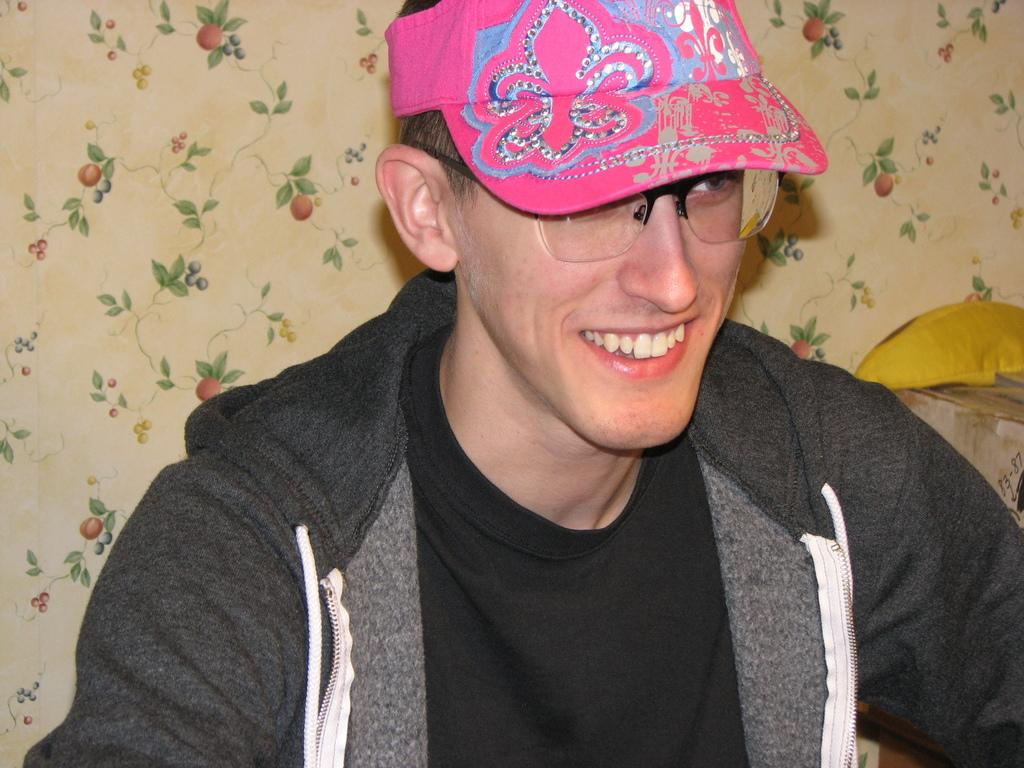Who is present in the image? There is a man in the image. What is the man wearing on his upper body? The man is wearing a jacket and a black color t-shirt. What is the man wearing on his head? The man is wearing a pink color cap on his head. What is the man's facial expression? The man is smiling. In which direction is the man looking? The man is looking at the right side. What can be seen at the back of the man? There is a curtain visible at the back of the man. Are there any cobwebs visible on the man's face in the image? No, there are no cobwebs visible on the man's face in the image. How many ears does the man have in the image? The man has two ears in the image, but the question is irrelevant as it does not pertain to any detail in the provided facts. Is there a cub playing with the man in the image? No, there is no cub present in the image. 